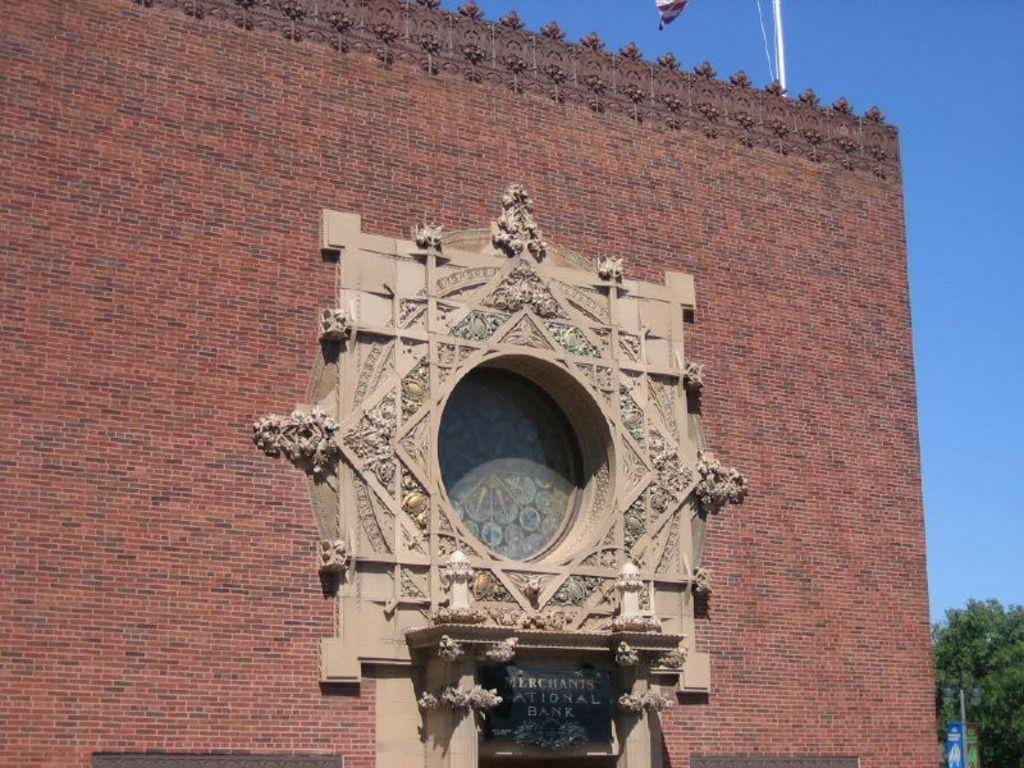Could you give a brief overview of what you see in this image? In this image, we can see the wall with some design and a board with some text. We can also see a pole with some cloth on the top of the wall. We can see some trees and objects on the bottom right corner. We can also see the sky. 